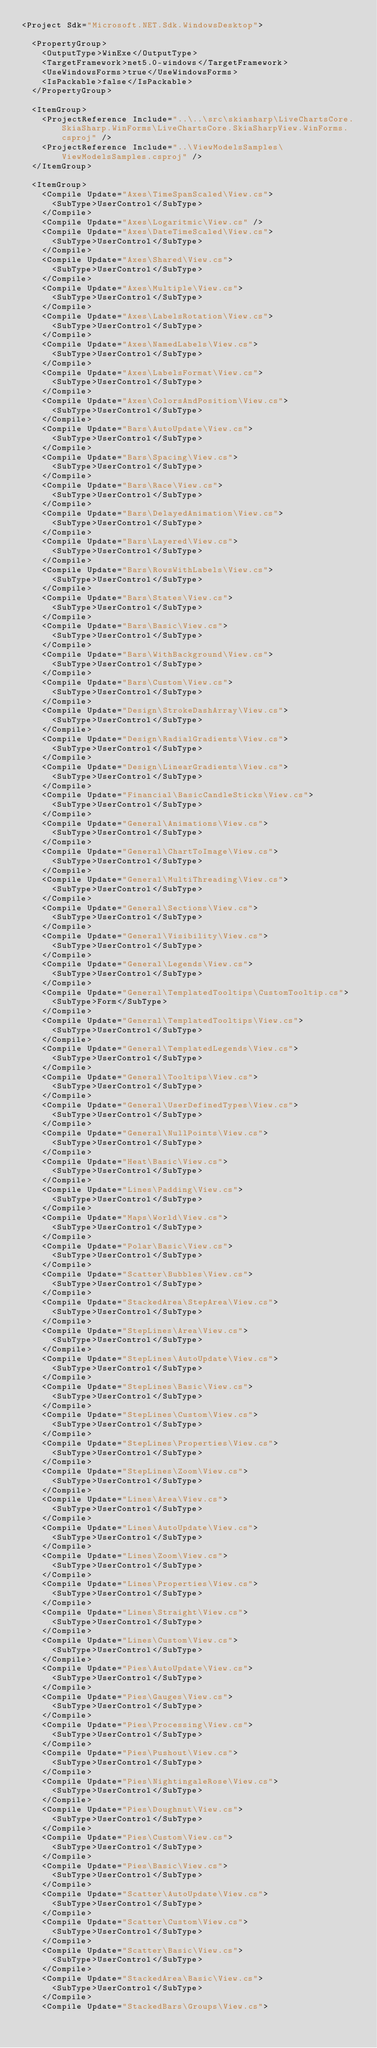Convert code to text. <code><loc_0><loc_0><loc_500><loc_500><_XML_><Project Sdk="Microsoft.NET.Sdk.WindowsDesktop">

  <PropertyGroup>
    <OutputType>WinExe</OutputType>
    <TargetFramework>net5.0-windows</TargetFramework>
    <UseWindowsForms>true</UseWindowsForms>
    <IsPackable>false</IsPackable>
  </PropertyGroup>

  <ItemGroup>
    <ProjectReference Include="..\..\src\skiasharp\LiveChartsCore.SkiaSharp.WinForms\LiveChartsCore.SkiaSharpView.WinForms.csproj" />
    <ProjectReference Include="..\ViewModelsSamples\ViewModelsSamples.csproj" />
  </ItemGroup>

  <ItemGroup>
    <Compile Update="Axes\TimeSpanScaled\View.cs">
      <SubType>UserControl</SubType>
    </Compile>
    <Compile Update="Axes\Logaritmic\View.cs" />
    <Compile Update="Axes\DateTimeScaled\View.cs">
      <SubType>UserControl</SubType>
    </Compile>
    <Compile Update="Axes\Shared\View.cs">
      <SubType>UserControl</SubType>
    </Compile>
    <Compile Update="Axes\Multiple\View.cs">
      <SubType>UserControl</SubType>
    </Compile>
    <Compile Update="Axes\LabelsRotation\View.cs">
      <SubType>UserControl</SubType>
    </Compile>
    <Compile Update="Axes\NamedLabels\View.cs">
      <SubType>UserControl</SubType>
    </Compile>
    <Compile Update="Axes\LabelsFormat\View.cs">
      <SubType>UserControl</SubType>
    </Compile>
    <Compile Update="Axes\ColorsAndPosition\View.cs">
      <SubType>UserControl</SubType>
    </Compile>
    <Compile Update="Bars\AutoUpdate\View.cs">
      <SubType>UserControl</SubType>
    </Compile>
    <Compile Update="Bars\Spacing\View.cs">
      <SubType>UserControl</SubType>
    </Compile>
    <Compile Update="Bars\Race\View.cs">
      <SubType>UserControl</SubType>
    </Compile>
    <Compile Update="Bars\DelayedAnimation\View.cs">
      <SubType>UserControl</SubType>
    </Compile>
    <Compile Update="Bars\Layered\View.cs">
      <SubType>UserControl</SubType>
    </Compile>
    <Compile Update="Bars\RowsWithLabels\View.cs">
      <SubType>UserControl</SubType>
    </Compile>
    <Compile Update="Bars\States\View.cs">
      <SubType>UserControl</SubType>
    </Compile>
    <Compile Update="Bars\Basic\View.cs">
      <SubType>UserControl</SubType>
    </Compile>
    <Compile Update="Bars\WithBackground\View.cs">
      <SubType>UserControl</SubType>
    </Compile>
    <Compile Update="Bars\Custom\View.cs">
      <SubType>UserControl</SubType>
    </Compile>
    <Compile Update="Design\StrokeDashArray\View.cs">
      <SubType>UserControl</SubType>
    </Compile>
    <Compile Update="Design\RadialGradients\View.cs">
      <SubType>UserControl</SubType>
    </Compile>
    <Compile Update="Design\LinearGradients\View.cs">
      <SubType>UserControl</SubType>
    </Compile>
    <Compile Update="Financial\BasicCandleSticks\View.cs">
      <SubType>UserControl</SubType>
    </Compile>
    <Compile Update="General\Animations\View.cs">
      <SubType>UserControl</SubType>
    </Compile>
    <Compile Update="General\ChartToImage\View.cs">
      <SubType>UserControl</SubType>
    </Compile>
    <Compile Update="General\MultiThreading\View.cs">
      <SubType>UserControl</SubType>
    </Compile>
    <Compile Update="General\Sections\View.cs">
      <SubType>UserControl</SubType>
    </Compile>
    <Compile Update="General\Visibility\View.cs">
      <SubType>UserControl</SubType>
    </Compile>
    <Compile Update="General\Legends\View.cs">
      <SubType>UserControl</SubType>
    </Compile>
    <Compile Update="General\TemplatedTooltips\CustomTooltip.cs">
      <SubType>Form</SubType>
    </Compile>
    <Compile Update="General\TemplatedTooltips\View.cs">
      <SubType>UserControl</SubType>
    </Compile>
    <Compile Update="General\TemplatedLegends\View.cs">
      <SubType>UserControl</SubType>
    </Compile>
    <Compile Update="General\Tooltips\View.cs">
      <SubType>UserControl</SubType>
    </Compile>
    <Compile Update="General\UserDefinedTypes\View.cs">
      <SubType>UserControl</SubType>
    </Compile>
    <Compile Update="General\NullPoints\View.cs">
      <SubType>UserControl</SubType>
    </Compile>
    <Compile Update="Heat\Basic\View.cs">
      <SubType>UserControl</SubType>
    </Compile>
    <Compile Update="Lines\Padding\View.cs">
      <SubType>UserControl</SubType>
    </Compile>
    <Compile Update="Maps\World\View.cs">
      <SubType>UserControl</SubType>
    </Compile>
    <Compile Update="Polar\Basic\View.cs">
      <SubType>UserControl</SubType>
    </Compile>
    <Compile Update="Scatter\Bubbles\View.cs">
      <SubType>UserControl</SubType>
    </Compile>
    <Compile Update="StackedArea\StepArea\View.cs">
      <SubType>UserControl</SubType>
    </Compile>
    <Compile Update="StepLines\Area\View.cs">
      <SubType>UserControl</SubType>
    </Compile>
    <Compile Update="StepLines\AutoUpdate\View.cs">
      <SubType>UserControl</SubType>
    </Compile>
    <Compile Update="StepLines\Basic\View.cs">
      <SubType>UserControl</SubType>
    </Compile>
    <Compile Update="StepLines\Custom\View.cs">
      <SubType>UserControl</SubType>
    </Compile>
    <Compile Update="StepLines\Properties\View.cs">
      <SubType>UserControl</SubType>
    </Compile>
    <Compile Update="StepLines\Zoom\View.cs">
      <SubType>UserControl</SubType>
    </Compile>
    <Compile Update="Lines\Area\View.cs">
      <SubType>UserControl</SubType>
    </Compile>
    <Compile Update="Lines\AutoUpdate\View.cs">
      <SubType>UserControl</SubType>
    </Compile>
    <Compile Update="Lines\Zoom\View.cs">
      <SubType>UserControl</SubType>
    </Compile>
    <Compile Update="Lines\Properties\View.cs">
      <SubType>UserControl</SubType>
    </Compile>
    <Compile Update="Lines\Straight\View.cs">
      <SubType>UserControl</SubType>
    </Compile>
    <Compile Update="Lines\Custom\View.cs">
      <SubType>UserControl</SubType>
    </Compile>
    <Compile Update="Pies\AutoUpdate\View.cs">
      <SubType>UserControl</SubType>
    </Compile>
    <Compile Update="Pies\Gauges\View.cs">
      <SubType>UserControl</SubType>
    </Compile>
    <Compile Update="Pies\Processing\View.cs">
      <SubType>UserControl</SubType>
    </Compile>
    <Compile Update="Pies\Pushout\View.cs">
      <SubType>UserControl</SubType>
    </Compile>
    <Compile Update="Pies\NightingaleRose\View.cs">
      <SubType>UserControl</SubType>
    </Compile>
    <Compile Update="Pies\Doughnut\View.cs">
      <SubType>UserControl</SubType>
    </Compile>
    <Compile Update="Pies\Custom\View.cs">
      <SubType>UserControl</SubType>
    </Compile>
    <Compile Update="Pies\Basic\View.cs">
      <SubType>UserControl</SubType>
    </Compile>
    <Compile Update="Scatter\AutoUpdate\View.cs">
      <SubType>UserControl</SubType>
    </Compile>
    <Compile Update="Scatter\Custom\View.cs">
      <SubType>UserControl</SubType>
    </Compile>
    <Compile Update="Scatter\Basic\View.cs">
      <SubType>UserControl</SubType>
    </Compile>
    <Compile Update="StackedArea\Basic\View.cs">
      <SubType>UserControl</SubType>
    </Compile>
    <Compile Update="StackedBars\Groups\View.cs"></code> 